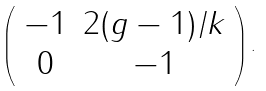Convert formula to latex. <formula><loc_0><loc_0><loc_500><loc_500>\left ( \begin{array} { c c } - 1 & 2 ( g - 1 ) / k \\ 0 & - 1 \end{array} \right ) .</formula> 